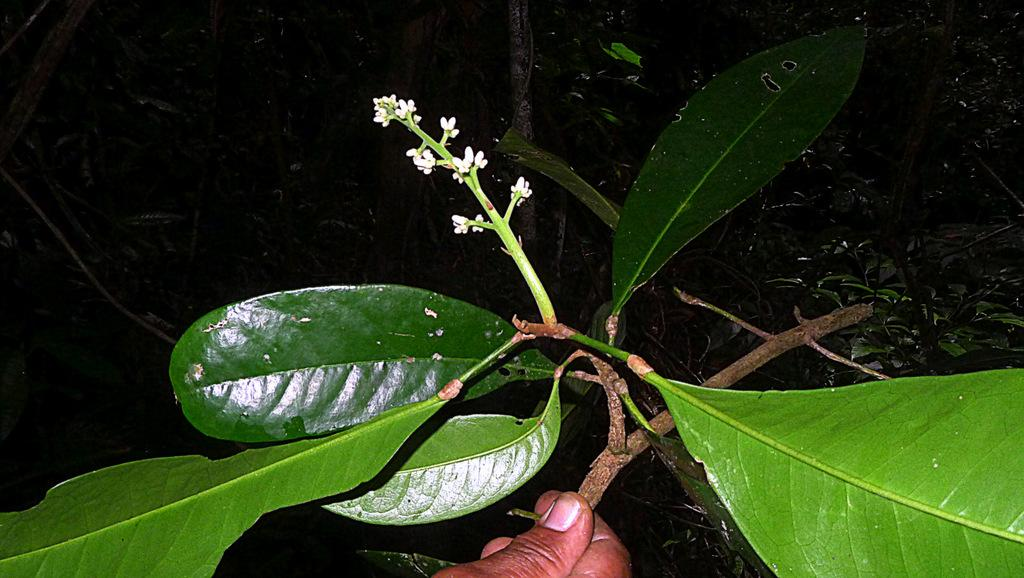What is present in the picture? There is a tree, a branch with a flower, and a human hand holding the branch in the picture. Can you describe the branch in the picture? The branch has a flower on it. What is the human hand doing in the picture? The human hand is holding the branch with the flower. Where is the dad in the picture? There is no dad present in the picture; it only features a tree, a branch with a flower, and a human hand holding the branch. Is there a boat in the picture? No, there is no boat in the picture. 